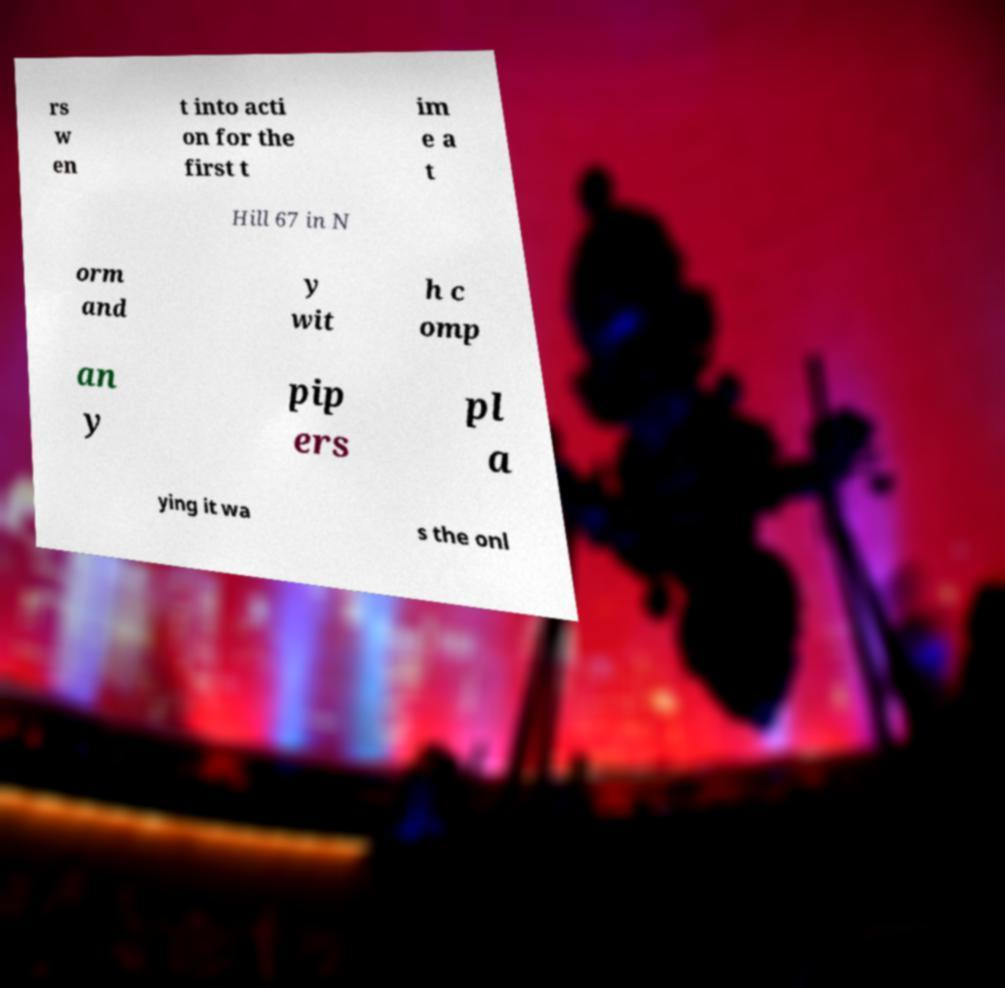Could you extract and type out the text from this image? rs w en t into acti on for the first t im e a t Hill 67 in N orm and y wit h c omp an y pip ers pl a ying it wa s the onl 